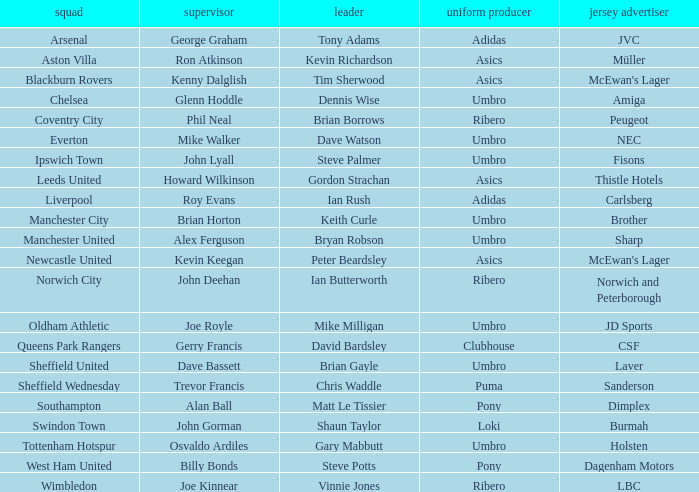Which captain has howard wilkinson as the manager? Gordon Strachan. 